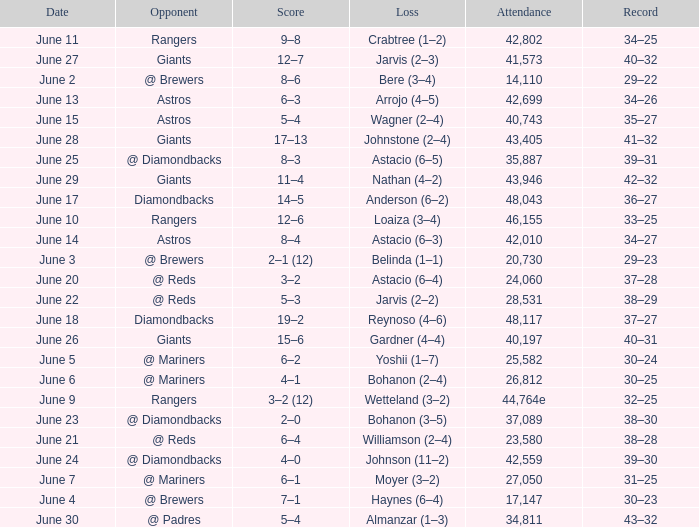Who's the opponent for June 13? Astros. 